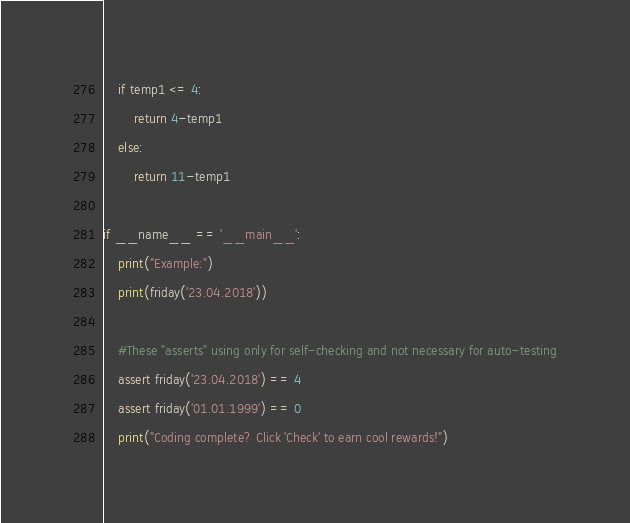<code> <loc_0><loc_0><loc_500><loc_500><_Python_>    if temp1 <= 4:
        return 4-temp1
    else:
        return 11-temp1

if __name__ == '__main__':
    print("Example:")
    print(friday('23.04.2018'))

    #These "asserts" using only for self-checking and not necessary for auto-testing
    assert friday('23.04.2018') == 4
    assert friday('01.01.1999') == 0
    print("Coding complete? Click 'Check' to earn cool rewards!")
</code> 